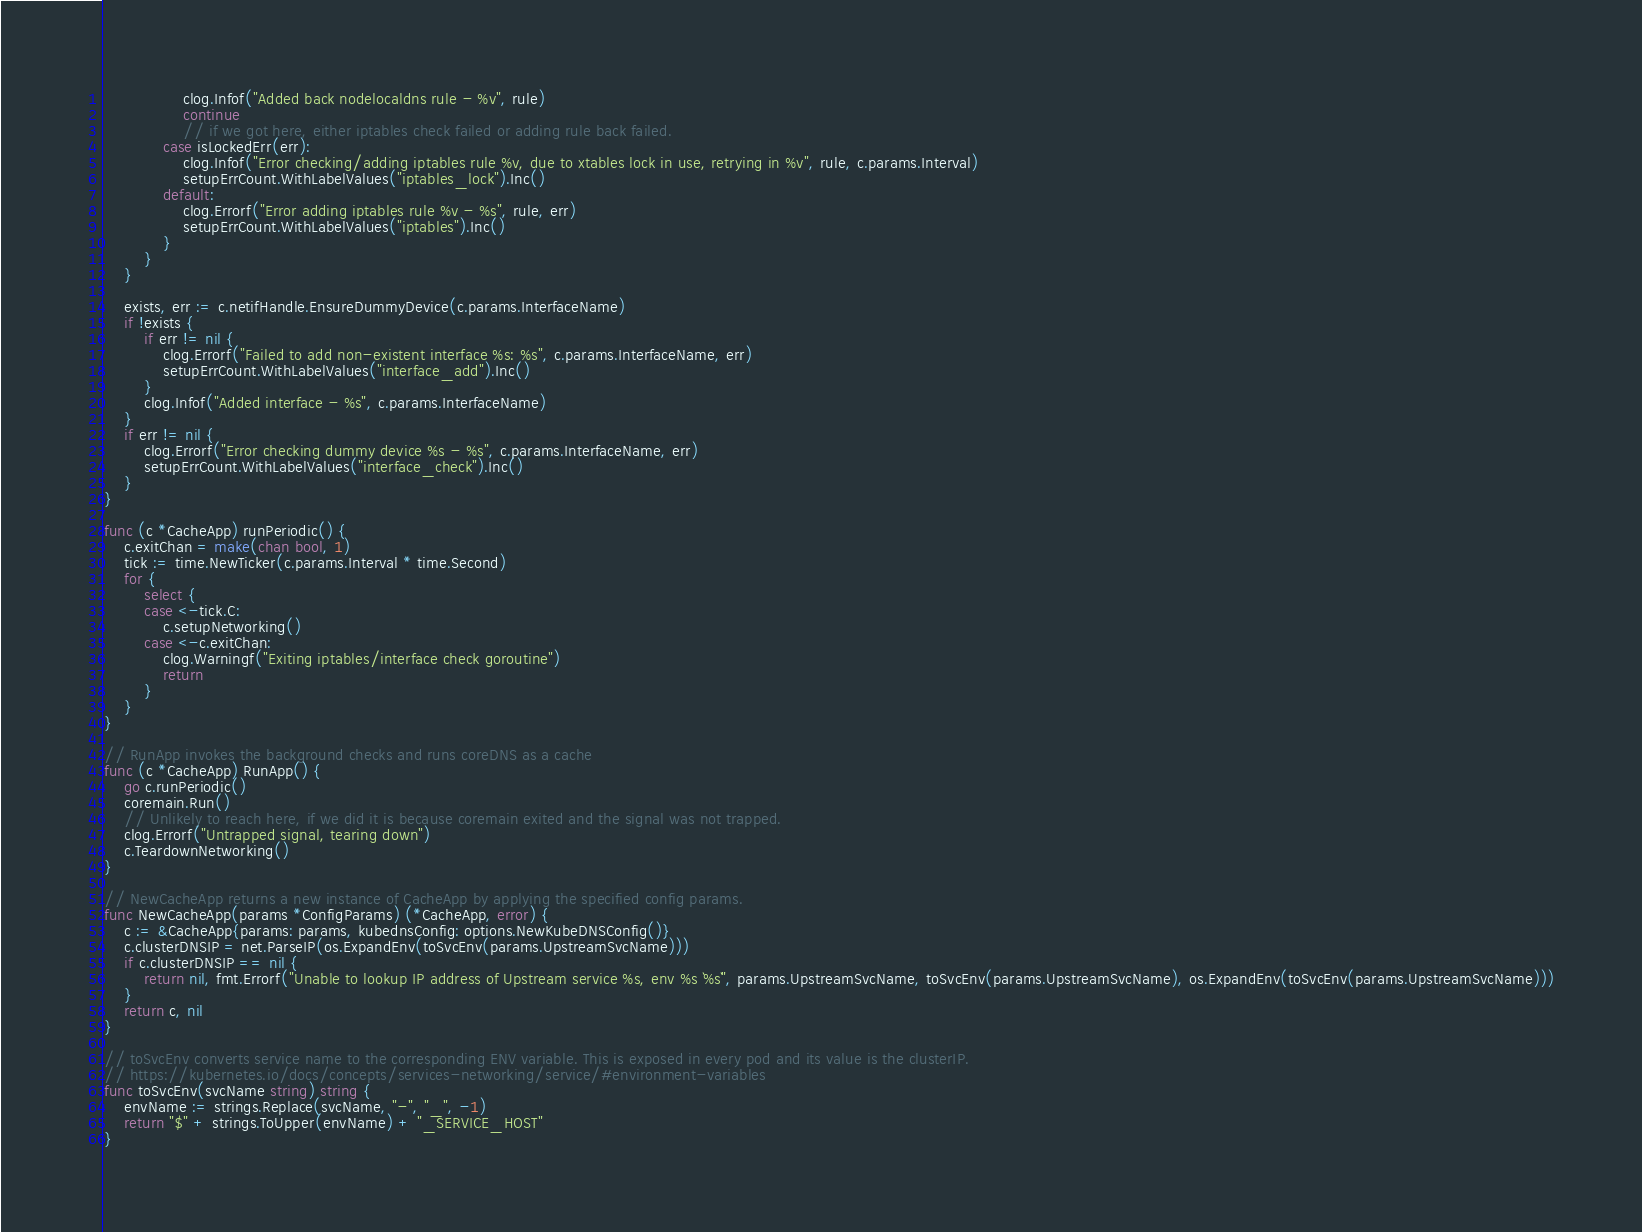<code> <loc_0><loc_0><loc_500><loc_500><_Go_>				clog.Infof("Added back nodelocaldns rule - %v", rule)
				continue
				// if we got here, either iptables check failed or adding rule back failed.
			case isLockedErr(err):
				clog.Infof("Error checking/adding iptables rule %v, due to xtables lock in use, retrying in %v", rule, c.params.Interval)
				setupErrCount.WithLabelValues("iptables_lock").Inc()
			default:
				clog.Errorf("Error adding iptables rule %v - %s", rule, err)
				setupErrCount.WithLabelValues("iptables").Inc()
			}
		}
	}

	exists, err := c.netifHandle.EnsureDummyDevice(c.params.InterfaceName)
	if !exists {
		if err != nil {
			clog.Errorf("Failed to add non-existent interface %s: %s", c.params.InterfaceName, err)
			setupErrCount.WithLabelValues("interface_add").Inc()
		}
		clog.Infof("Added interface - %s", c.params.InterfaceName)
	}
	if err != nil {
		clog.Errorf("Error checking dummy device %s - %s", c.params.InterfaceName, err)
		setupErrCount.WithLabelValues("interface_check").Inc()
	}
}

func (c *CacheApp) runPeriodic() {
	c.exitChan = make(chan bool, 1)
	tick := time.NewTicker(c.params.Interval * time.Second)
	for {
		select {
		case <-tick.C:
			c.setupNetworking()
		case <-c.exitChan:
			clog.Warningf("Exiting iptables/interface check goroutine")
			return
		}
	}
}

// RunApp invokes the background checks and runs coreDNS as a cache
func (c *CacheApp) RunApp() {
	go c.runPeriodic()
	coremain.Run()
	// Unlikely to reach here, if we did it is because coremain exited and the signal was not trapped.
	clog.Errorf("Untrapped signal, tearing down")
	c.TeardownNetworking()
}

// NewCacheApp returns a new instance of CacheApp by applying the specified config params.
func NewCacheApp(params *ConfigParams) (*CacheApp, error) {
	c := &CacheApp{params: params, kubednsConfig: options.NewKubeDNSConfig()}
	c.clusterDNSIP = net.ParseIP(os.ExpandEnv(toSvcEnv(params.UpstreamSvcName)))
	if c.clusterDNSIP == nil {
		return nil, fmt.Errorf("Unable to lookup IP address of Upstream service %s, env %s `%s`", params.UpstreamSvcName, toSvcEnv(params.UpstreamSvcName), os.ExpandEnv(toSvcEnv(params.UpstreamSvcName)))
	}
	return c, nil
}

// toSvcEnv converts service name to the corresponding ENV variable. This is exposed in every pod and its value is the clusterIP.
// https://kubernetes.io/docs/concepts/services-networking/service/#environment-variables
func toSvcEnv(svcName string) string {
	envName := strings.Replace(svcName, "-", "_", -1)
	return "$" + strings.ToUpper(envName) + "_SERVICE_HOST"
}
</code> 